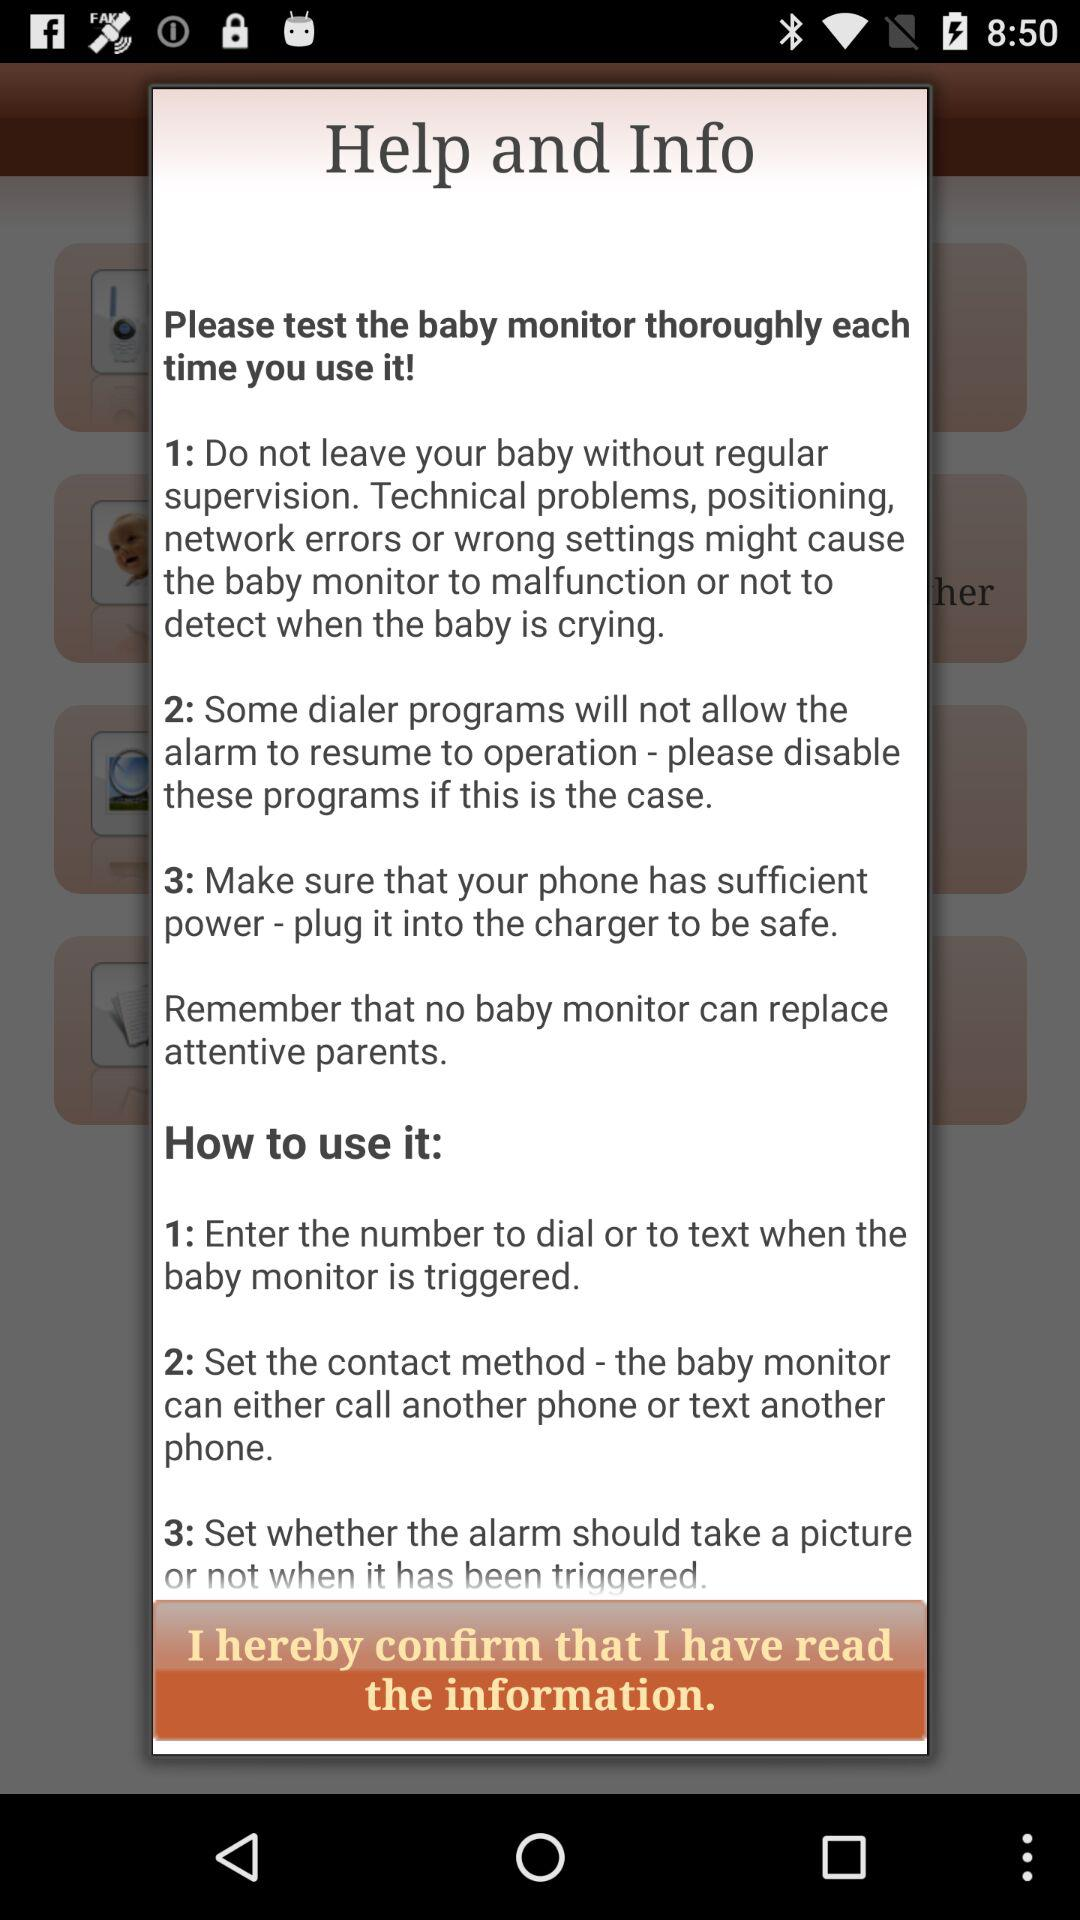What are the steps to test baby monitor every time?
Answer the question using a single word or phrase. The steps are: "1: Do not leave baby without regular supervision. Technical problems, positioning, network errors or wrong settings might cause the baby monitor to malfunction or not to detect when the baby is crying.", 2: Some dialer programs will not allow the alarm to resume operation—please disable these programs if this is the case. " 3: Make sure that your phone has sufficient power-plug it into the charger to be safe." 